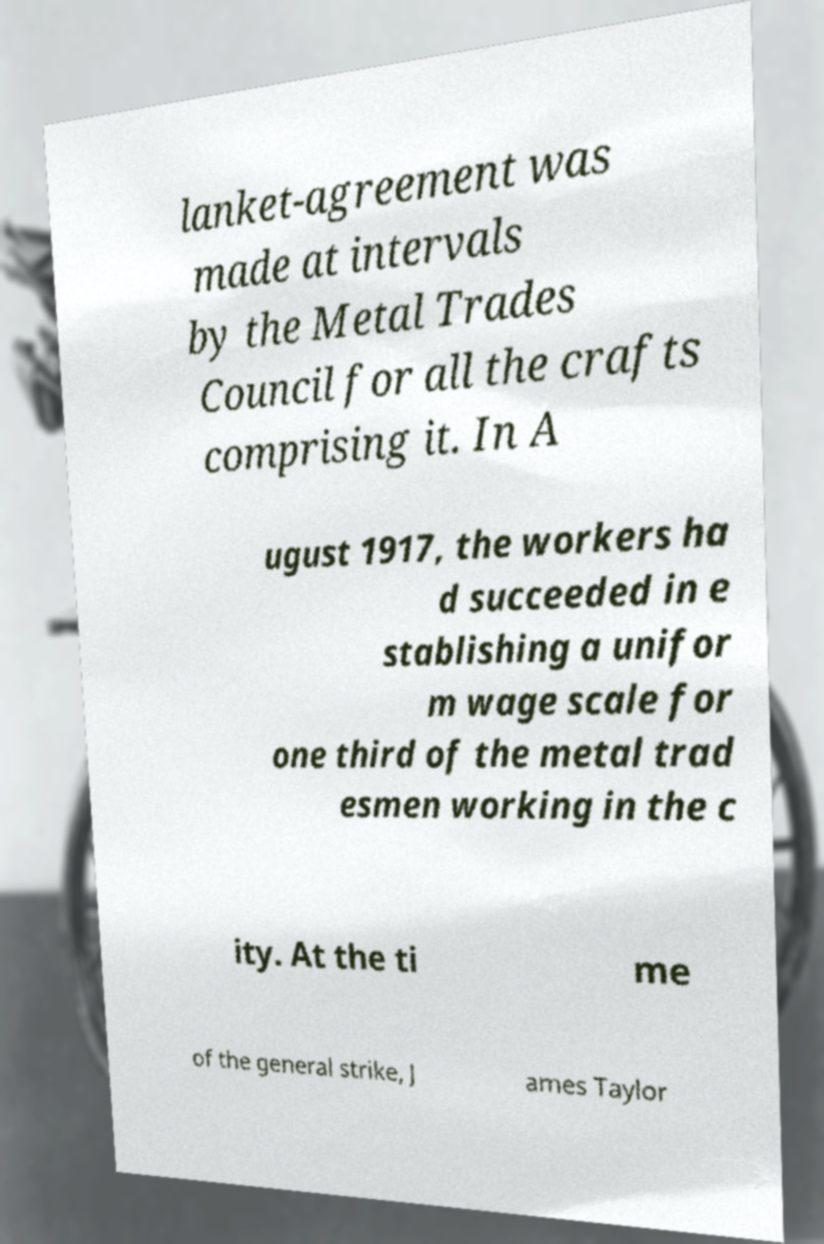Please identify and transcribe the text found in this image. lanket-agreement was made at intervals by the Metal Trades Council for all the crafts comprising it. In A ugust 1917, the workers ha d succeeded in e stablishing a unifor m wage scale for one third of the metal trad esmen working in the c ity. At the ti me of the general strike, J ames Taylor 